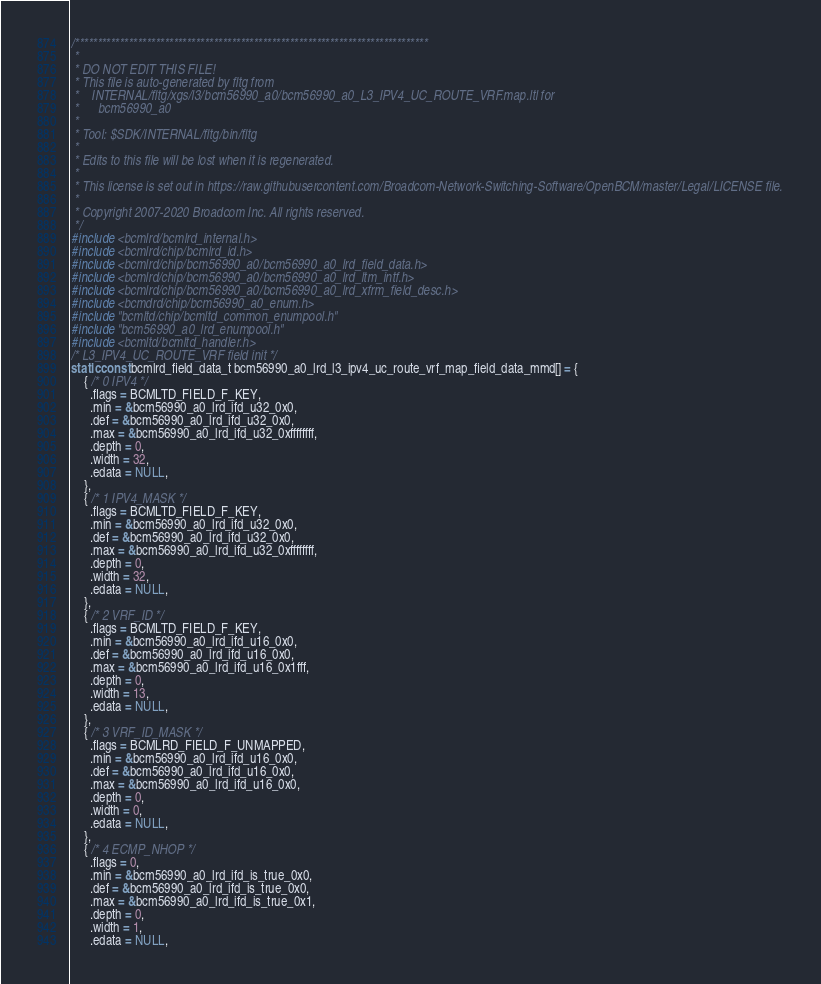Convert code to text. <code><loc_0><loc_0><loc_500><loc_500><_C_>/*******************************************************************************
 *
 * DO NOT EDIT THIS FILE!
 * This file is auto-generated by fltg from
 *    INTERNAL/fltg/xgs/l3/bcm56990_a0/bcm56990_a0_L3_IPV4_UC_ROUTE_VRF.map.ltl for
 *      bcm56990_a0
 *
 * Tool: $SDK/INTERNAL/fltg/bin/fltg
 *
 * Edits to this file will be lost when it is regenerated.
 *
 * This license is set out in https://raw.githubusercontent.com/Broadcom-Network-Switching-Software/OpenBCM/master/Legal/LICENSE file.
 * 
 * Copyright 2007-2020 Broadcom Inc. All rights reserved.
 */
#include <bcmlrd/bcmlrd_internal.h>
#include <bcmlrd/chip/bcmlrd_id.h>
#include <bcmlrd/chip/bcm56990_a0/bcm56990_a0_lrd_field_data.h>
#include <bcmlrd/chip/bcm56990_a0/bcm56990_a0_lrd_ltm_intf.h>
#include <bcmlrd/chip/bcm56990_a0/bcm56990_a0_lrd_xfrm_field_desc.h>
#include <bcmdrd/chip/bcm56990_a0_enum.h>
#include "bcmltd/chip/bcmltd_common_enumpool.h"
#include "bcm56990_a0_lrd_enumpool.h"
#include <bcmltd/bcmltd_handler.h>
/* L3_IPV4_UC_ROUTE_VRF field init */
static const bcmlrd_field_data_t bcm56990_a0_lrd_l3_ipv4_uc_route_vrf_map_field_data_mmd[] = {
    { /* 0 IPV4 */
      .flags = BCMLTD_FIELD_F_KEY,
      .min = &bcm56990_a0_lrd_ifd_u32_0x0,
      .def = &bcm56990_a0_lrd_ifd_u32_0x0,
      .max = &bcm56990_a0_lrd_ifd_u32_0xffffffff,
      .depth = 0,
      .width = 32,
      .edata = NULL,
    },
    { /* 1 IPV4_MASK */
      .flags = BCMLTD_FIELD_F_KEY,
      .min = &bcm56990_a0_lrd_ifd_u32_0x0,
      .def = &bcm56990_a0_lrd_ifd_u32_0x0,
      .max = &bcm56990_a0_lrd_ifd_u32_0xffffffff,
      .depth = 0,
      .width = 32,
      .edata = NULL,
    },
    { /* 2 VRF_ID */
      .flags = BCMLTD_FIELD_F_KEY,
      .min = &bcm56990_a0_lrd_ifd_u16_0x0,
      .def = &bcm56990_a0_lrd_ifd_u16_0x0,
      .max = &bcm56990_a0_lrd_ifd_u16_0x1fff,
      .depth = 0,
      .width = 13,
      .edata = NULL,
    },
    { /* 3 VRF_ID_MASK */
      .flags = BCMLRD_FIELD_F_UNMAPPED,
      .min = &bcm56990_a0_lrd_ifd_u16_0x0,
      .def = &bcm56990_a0_lrd_ifd_u16_0x0,
      .max = &bcm56990_a0_lrd_ifd_u16_0x0,
      .depth = 0,
      .width = 0,
      .edata = NULL,
    },
    { /* 4 ECMP_NHOP */
      .flags = 0,
      .min = &bcm56990_a0_lrd_ifd_is_true_0x0,
      .def = &bcm56990_a0_lrd_ifd_is_true_0x0,
      .max = &bcm56990_a0_lrd_ifd_is_true_0x1,
      .depth = 0,
      .width = 1,
      .edata = NULL,</code> 